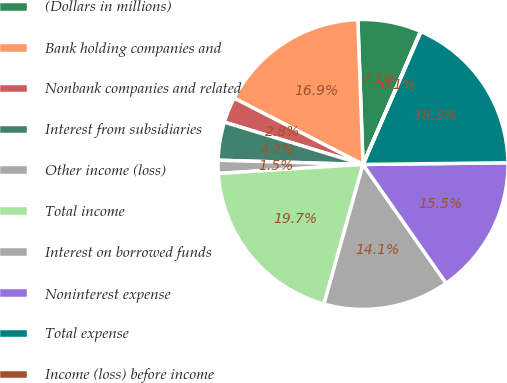<chart> <loc_0><loc_0><loc_500><loc_500><pie_chart><fcel>(Dollars in millions)<fcel>Bank holding companies and<fcel>Nonbank companies and related<fcel>Interest from subsidiaries<fcel>Other income (loss)<fcel>Total income<fcel>Interest on borrowed funds<fcel>Noninterest expense<fcel>Total expense<fcel>Income (loss) before income<nl><fcel>7.06%<fcel>16.87%<fcel>2.85%<fcel>4.25%<fcel>1.45%<fcel>19.67%<fcel>14.06%<fcel>15.47%<fcel>18.27%<fcel>0.05%<nl></chart> 